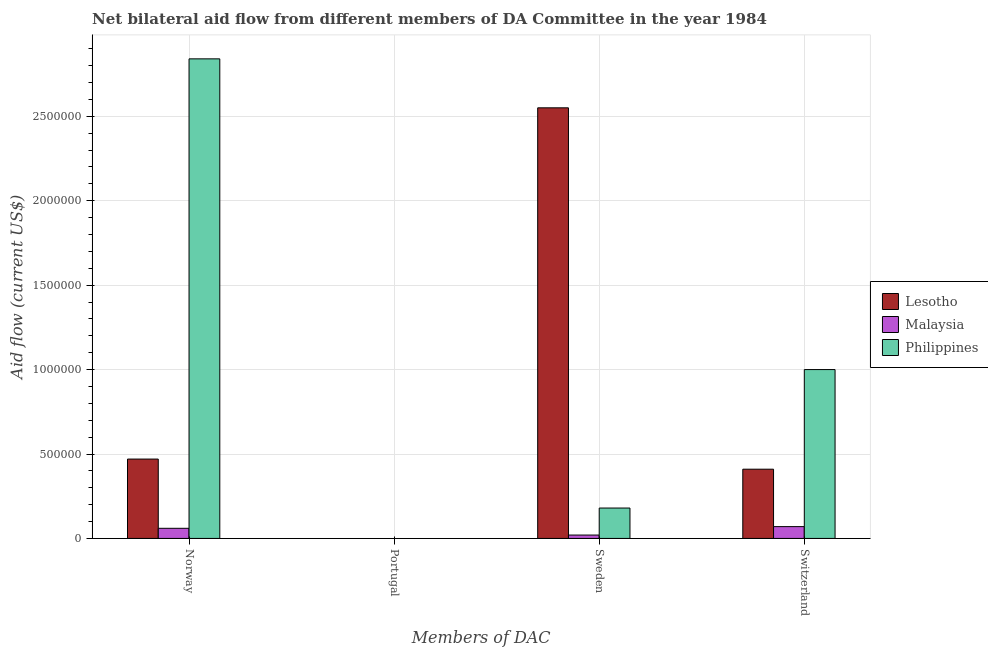How many different coloured bars are there?
Make the answer very short. 3. Are the number of bars per tick equal to the number of legend labels?
Your response must be concise. No. Are the number of bars on each tick of the X-axis equal?
Offer a very short reply. No. How many bars are there on the 1st tick from the right?
Your answer should be compact. 3. What is the label of the 3rd group of bars from the left?
Provide a succinct answer. Sweden. What is the amount of aid given by norway in Philippines?
Give a very brief answer. 2.84e+06. Across all countries, what is the maximum amount of aid given by norway?
Keep it short and to the point. 2.84e+06. What is the total amount of aid given by norway in the graph?
Ensure brevity in your answer.  3.37e+06. What is the difference between the amount of aid given by sweden in Lesotho and that in Malaysia?
Make the answer very short. 2.53e+06. What is the difference between the amount of aid given by switzerland in Philippines and the amount of aid given by sweden in Lesotho?
Your response must be concise. -1.55e+06. What is the average amount of aid given by switzerland per country?
Keep it short and to the point. 4.93e+05. What is the difference between the amount of aid given by sweden and amount of aid given by norway in Lesotho?
Ensure brevity in your answer.  2.08e+06. What is the ratio of the amount of aid given by switzerland in Philippines to that in Malaysia?
Provide a succinct answer. 14.29. What is the difference between the highest and the second highest amount of aid given by sweden?
Make the answer very short. 2.37e+06. What is the difference between the highest and the lowest amount of aid given by sweden?
Make the answer very short. 2.53e+06. Is it the case that in every country, the sum of the amount of aid given by norway and amount of aid given by portugal is greater than the amount of aid given by sweden?
Your answer should be very brief. No. How many countries are there in the graph?
Give a very brief answer. 3. What is the difference between two consecutive major ticks on the Y-axis?
Your response must be concise. 5.00e+05. Are the values on the major ticks of Y-axis written in scientific E-notation?
Give a very brief answer. No. Does the graph contain any zero values?
Offer a very short reply. Yes. Where does the legend appear in the graph?
Ensure brevity in your answer.  Center right. What is the title of the graph?
Your answer should be compact. Net bilateral aid flow from different members of DA Committee in the year 1984. Does "High income" appear as one of the legend labels in the graph?
Provide a short and direct response. No. What is the label or title of the X-axis?
Offer a very short reply. Members of DAC. What is the Aid flow (current US$) of Philippines in Norway?
Offer a terse response. 2.84e+06. What is the Aid flow (current US$) in Lesotho in Portugal?
Provide a succinct answer. Nan. What is the Aid flow (current US$) of Malaysia in Portugal?
Your answer should be compact. Nan. What is the Aid flow (current US$) of Philippines in Portugal?
Give a very brief answer. Nan. What is the Aid flow (current US$) in Lesotho in Sweden?
Offer a very short reply. 2.55e+06. What is the Aid flow (current US$) of Philippines in Sweden?
Offer a terse response. 1.80e+05. Across all Members of DAC, what is the maximum Aid flow (current US$) of Lesotho?
Your response must be concise. 2.55e+06. Across all Members of DAC, what is the maximum Aid flow (current US$) of Philippines?
Make the answer very short. 2.84e+06. Across all Members of DAC, what is the minimum Aid flow (current US$) of Philippines?
Your answer should be compact. 1.80e+05. What is the total Aid flow (current US$) in Lesotho in the graph?
Provide a succinct answer. 3.43e+06. What is the total Aid flow (current US$) of Malaysia in the graph?
Provide a succinct answer. 1.50e+05. What is the total Aid flow (current US$) in Philippines in the graph?
Provide a succinct answer. 4.02e+06. What is the difference between the Aid flow (current US$) of Lesotho in Norway and that in Portugal?
Ensure brevity in your answer.  Nan. What is the difference between the Aid flow (current US$) in Malaysia in Norway and that in Portugal?
Give a very brief answer. Nan. What is the difference between the Aid flow (current US$) of Philippines in Norway and that in Portugal?
Make the answer very short. Nan. What is the difference between the Aid flow (current US$) in Lesotho in Norway and that in Sweden?
Your answer should be very brief. -2.08e+06. What is the difference between the Aid flow (current US$) of Malaysia in Norway and that in Sweden?
Offer a very short reply. 4.00e+04. What is the difference between the Aid flow (current US$) of Philippines in Norway and that in Sweden?
Give a very brief answer. 2.66e+06. What is the difference between the Aid flow (current US$) of Philippines in Norway and that in Switzerland?
Keep it short and to the point. 1.84e+06. What is the difference between the Aid flow (current US$) in Lesotho in Portugal and that in Sweden?
Make the answer very short. Nan. What is the difference between the Aid flow (current US$) in Malaysia in Portugal and that in Sweden?
Ensure brevity in your answer.  Nan. What is the difference between the Aid flow (current US$) in Philippines in Portugal and that in Sweden?
Give a very brief answer. Nan. What is the difference between the Aid flow (current US$) of Lesotho in Portugal and that in Switzerland?
Give a very brief answer. Nan. What is the difference between the Aid flow (current US$) in Malaysia in Portugal and that in Switzerland?
Make the answer very short. Nan. What is the difference between the Aid flow (current US$) of Philippines in Portugal and that in Switzerland?
Offer a very short reply. Nan. What is the difference between the Aid flow (current US$) in Lesotho in Sweden and that in Switzerland?
Your response must be concise. 2.14e+06. What is the difference between the Aid flow (current US$) in Philippines in Sweden and that in Switzerland?
Offer a terse response. -8.20e+05. What is the difference between the Aid flow (current US$) in Lesotho in Norway and the Aid flow (current US$) in Malaysia in Portugal?
Your answer should be very brief. Nan. What is the difference between the Aid flow (current US$) in Lesotho in Norway and the Aid flow (current US$) in Philippines in Portugal?
Offer a terse response. Nan. What is the difference between the Aid flow (current US$) of Malaysia in Norway and the Aid flow (current US$) of Philippines in Portugal?
Provide a succinct answer. Nan. What is the difference between the Aid flow (current US$) of Lesotho in Norway and the Aid flow (current US$) of Malaysia in Sweden?
Offer a very short reply. 4.50e+05. What is the difference between the Aid flow (current US$) of Lesotho in Norway and the Aid flow (current US$) of Philippines in Sweden?
Offer a very short reply. 2.90e+05. What is the difference between the Aid flow (current US$) in Malaysia in Norway and the Aid flow (current US$) in Philippines in Sweden?
Keep it short and to the point. -1.20e+05. What is the difference between the Aid flow (current US$) of Lesotho in Norway and the Aid flow (current US$) of Malaysia in Switzerland?
Your answer should be compact. 4.00e+05. What is the difference between the Aid flow (current US$) of Lesotho in Norway and the Aid flow (current US$) of Philippines in Switzerland?
Your response must be concise. -5.30e+05. What is the difference between the Aid flow (current US$) of Malaysia in Norway and the Aid flow (current US$) of Philippines in Switzerland?
Make the answer very short. -9.40e+05. What is the difference between the Aid flow (current US$) of Lesotho in Portugal and the Aid flow (current US$) of Malaysia in Sweden?
Provide a succinct answer. Nan. What is the difference between the Aid flow (current US$) in Lesotho in Portugal and the Aid flow (current US$) in Philippines in Sweden?
Provide a short and direct response. Nan. What is the difference between the Aid flow (current US$) in Malaysia in Portugal and the Aid flow (current US$) in Philippines in Sweden?
Your answer should be compact. Nan. What is the difference between the Aid flow (current US$) in Lesotho in Portugal and the Aid flow (current US$) in Malaysia in Switzerland?
Give a very brief answer. Nan. What is the difference between the Aid flow (current US$) in Lesotho in Portugal and the Aid flow (current US$) in Philippines in Switzerland?
Give a very brief answer. Nan. What is the difference between the Aid flow (current US$) in Malaysia in Portugal and the Aid flow (current US$) in Philippines in Switzerland?
Offer a terse response. Nan. What is the difference between the Aid flow (current US$) in Lesotho in Sweden and the Aid flow (current US$) in Malaysia in Switzerland?
Offer a terse response. 2.48e+06. What is the difference between the Aid flow (current US$) in Lesotho in Sweden and the Aid flow (current US$) in Philippines in Switzerland?
Your answer should be very brief. 1.55e+06. What is the difference between the Aid flow (current US$) of Malaysia in Sweden and the Aid flow (current US$) of Philippines in Switzerland?
Give a very brief answer. -9.80e+05. What is the average Aid flow (current US$) of Lesotho per Members of DAC?
Offer a very short reply. 8.58e+05. What is the average Aid flow (current US$) of Malaysia per Members of DAC?
Give a very brief answer. 3.75e+04. What is the average Aid flow (current US$) of Philippines per Members of DAC?
Provide a short and direct response. 1.00e+06. What is the difference between the Aid flow (current US$) of Lesotho and Aid flow (current US$) of Malaysia in Norway?
Offer a very short reply. 4.10e+05. What is the difference between the Aid flow (current US$) of Lesotho and Aid flow (current US$) of Philippines in Norway?
Your answer should be compact. -2.37e+06. What is the difference between the Aid flow (current US$) in Malaysia and Aid flow (current US$) in Philippines in Norway?
Your answer should be very brief. -2.78e+06. What is the difference between the Aid flow (current US$) of Lesotho and Aid flow (current US$) of Malaysia in Portugal?
Offer a very short reply. Nan. What is the difference between the Aid flow (current US$) of Lesotho and Aid flow (current US$) of Philippines in Portugal?
Your answer should be compact. Nan. What is the difference between the Aid flow (current US$) in Malaysia and Aid flow (current US$) in Philippines in Portugal?
Make the answer very short. Nan. What is the difference between the Aid flow (current US$) in Lesotho and Aid flow (current US$) in Malaysia in Sweden?
Your response must be concise. 2.53e+06. What is the difference between the Aid flow (current US$) of Lesotho and Aid flow (current US$) of Philippines in Sweden?
Make the answer very short. 2.37e+06. What is the difference between the Aid flow (current US$) of Lesotho and Aid flow (current US$) of Philippines in Switzerland?
Ensure brevity in your answer.  -5.90e+05. What is the difference between the Aid flow (current US$) in Malaysia and Aid flow (current US$) in Philippines in Switzerland?
Your response must be concise. -9.30e+05. What is the ratio of the Aid flow (current US$) of Lesotho in Norway to that in Portugal?
Give a very brief answer. Nan. What is the ratio of the Aid flow (current US$) in Malaysia in Norway to that in Portugal?
Make the answer very short. Nan. What is the ratio of the Aid flow (current US$) of Philippines in Norway to that in Portugal?
Offer a very short reply. Nan. What is the ratio of the Aid flow (current US$) of Lesotho in Norway to that in Sweden?
Your response must be concise. 0.18. What is the ratio of the Aid flow (current US$) in Philippines in Norway to that in Sweden?
Your answer should be very brief. 15.78. What is the ratio of the Aid flow (current US$) of Lesotho in Norway to that in Switzerland?
Offer a very short reply. 1.15. What is the ratio of the Aid flow (current US$) of Malaysia in Norway to that in Switzerland?
Your answer should be compact. 0.86. What is the ratio of the Aid flow (current US$) of Philippines in Norway to that in Switzerland?
Offer a terse response. 2.84. What is the ratio of the Aid flow (current US$) of Lesotho in Portugal to that in Sweden?
Keep it short and to the point. Nan. What is the ratio of the Aid flow (current US$) of Malaysia in Portugal to that in Sweden?
Provide a succinct answer. Nan. What is the ratio of the Aid flow (current US$) in Philippines in Portugal to that in Sweden?
Keep it short and to the point. Nan. What is the ratio of the Aid flow (current US$) of Lesotho in Portugal to that in Switzerland?
Your answer should be compact. Nan. What is the ratio of the Aid flow (current US$) in Malaysia in Portugal to that in Switzerland?
Ensure brevity in your answer.  Nan. What is the ratio of the Aid flow (current US$) of Philippines in Portugal to that in Switzerland?
Provide a succinct answer. Nan. What is the ratio of the Aid flow (current US$) in Lesotho in Sweden to that in Switzerland?
Offer a very short reply. 6.22. What is the ratio of the Aid flow (current US$) of Malaysia in Sweden to that in Switzerland?
Keep it short and to the point. 0.29. What is the ratio of the Aid flow (current US$) of Philippines in Sweden to that in Switzerland?
Offer a very short reply. 0.18. What is the difference between the highest and the second highest Aid flow (current US$) in Lesotho?
Give a very brief answer. 2.08e+06. What is the difference between the highest and the second highest Aid flow (current US$) in Philippines?
Give a very brief answer. 1.84e+06. What is the difference between the highest and the lowest Aid flow (current US$) in Lesotho?
Ensure brevity in your answer.  2.14e+06. What is the difference between the highest and the lowest Aid flow (current US$) in Malaysia?
Offer a terse response. 5.00e+04. What is the difference between the highest and the lowest Aid flow (current US$) of Philippines?
Provide a succinct answer. 2.66e+06. 